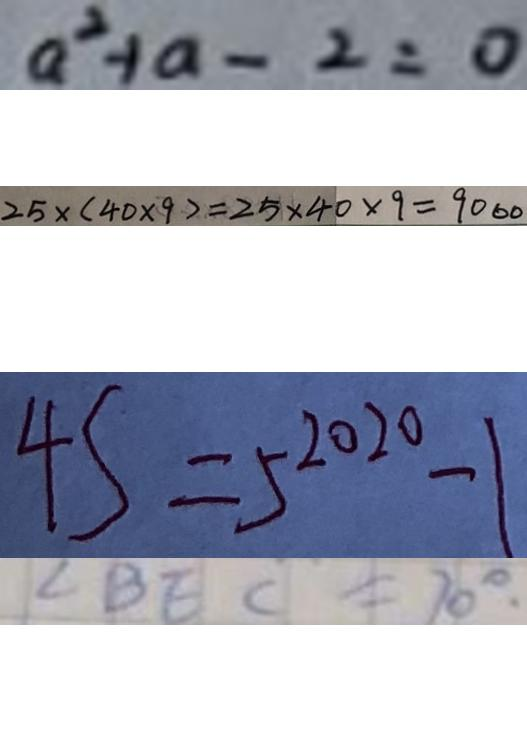<formula> <loc_0><loc_0><loc_500><loc_500>a ^ { 2 } + a - 2 = 0 
 2 5 \times ( 4 0 \times 9 ) = 2 5 \times 4 0 \times 9 = 9 0 0 0 
 4 S = 5 ^ { 2 0 2 0 } - 1 
 \angle B E C = 7 0 ^ { \circ } .</formula> 